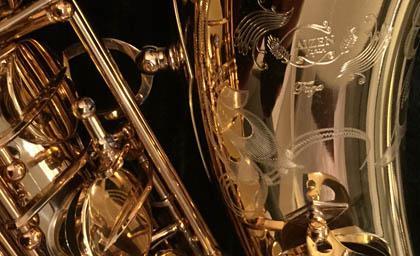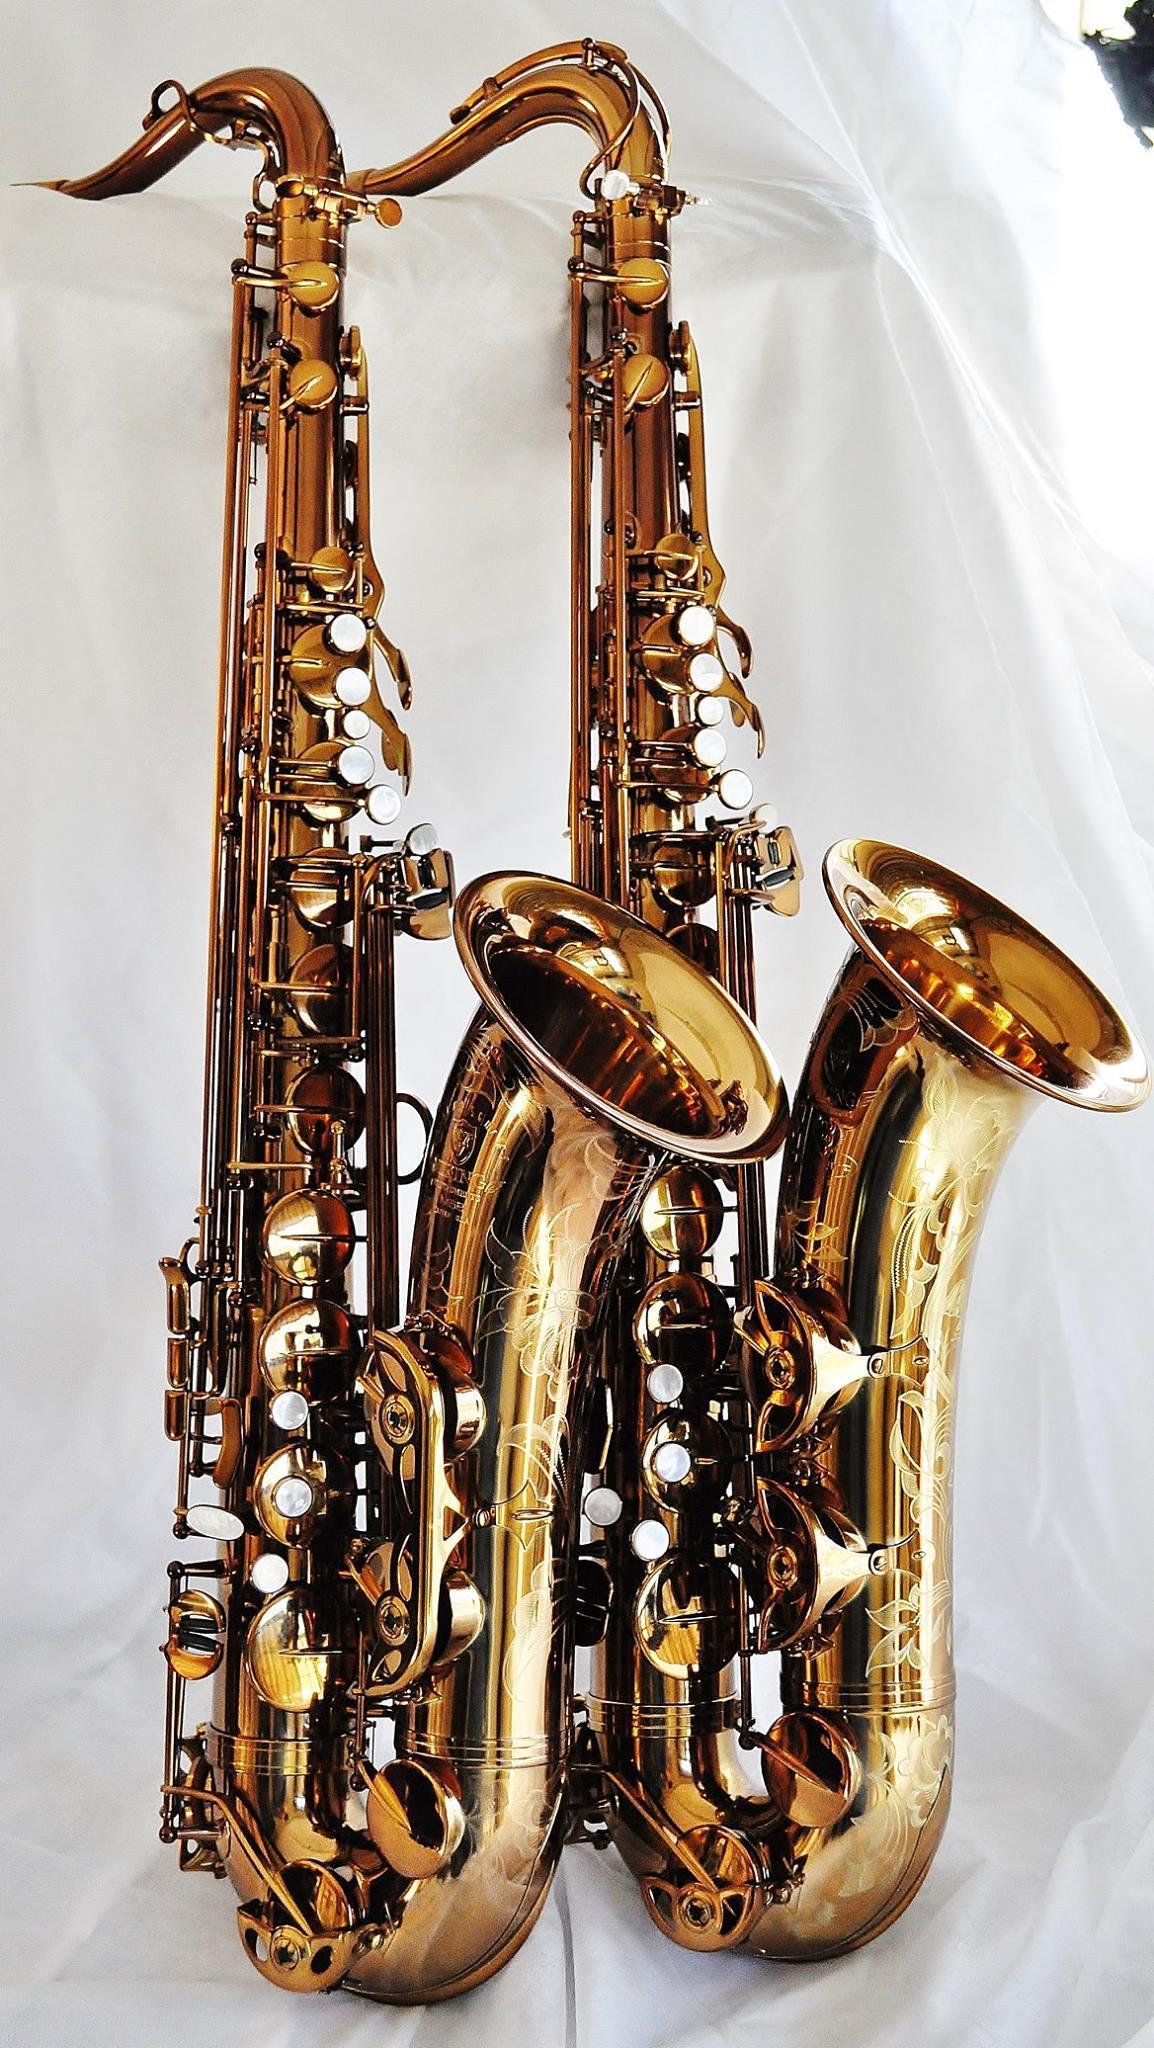The first image is the image on the left, the second image is the image on the right. For the images shown, is this caption "At least two intact brass-colored saxophones are displayed with the bell facing rightward." true? Answer yes or no. Yes. 